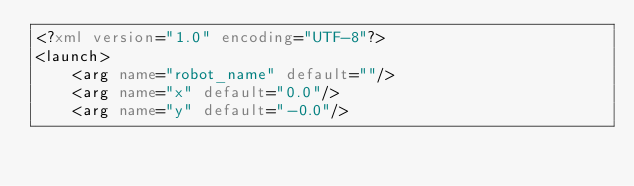Convert code to text. <code><loc_0><loc_0><loc_500><loc_500><_XML_><?xml version="1.0" encoding="UTF-8"?>
<launch>
    <arg name="robot_name" default=""/>
    <arg name="x" default="0.0"/>
    <arg name="y" default="-0.0"/></code> 